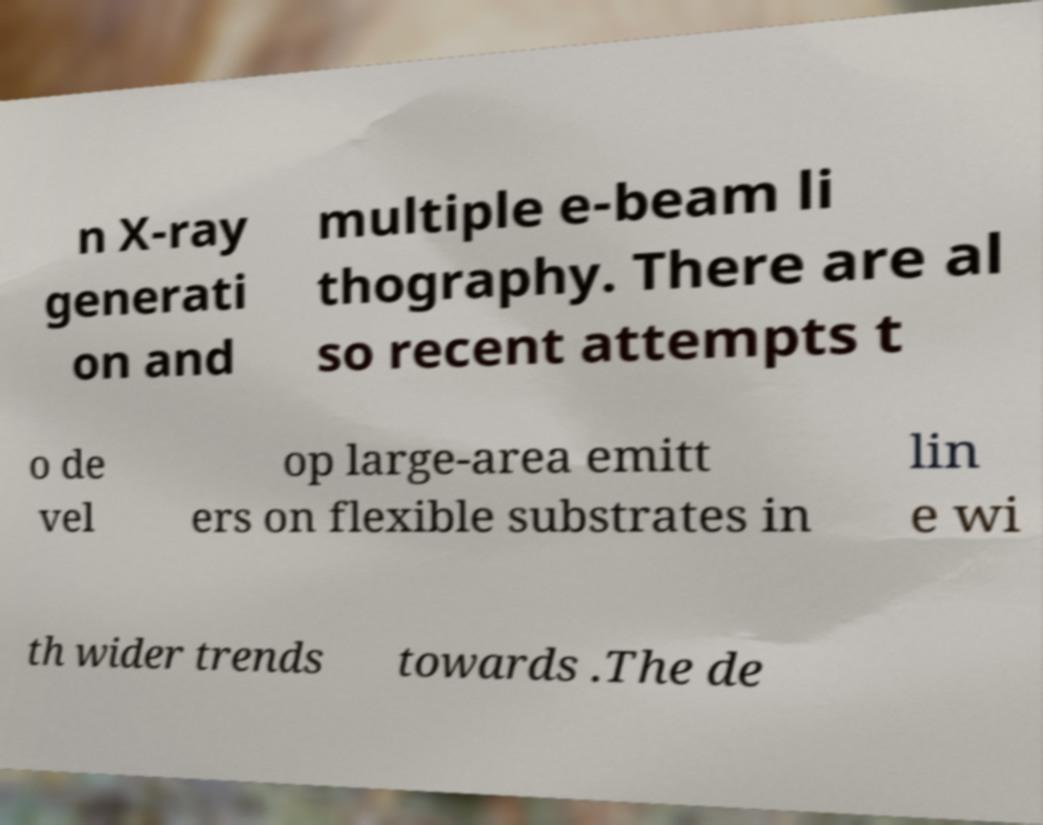Can you accurately transcribe the text from the provided image for me? n X-ray generati on and multiple e-beam li thography. There are al so recent attempts t o de vel op large-area emitt ers on flexible substrates in lin e wi th wider trends towards .The de 